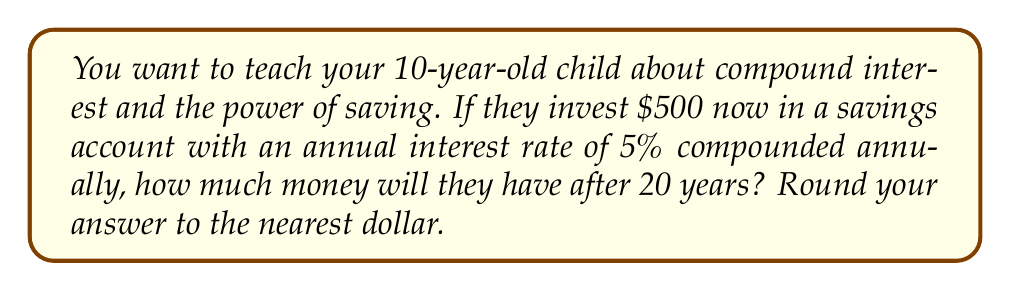Provide a solution to this math problem. To solve this problem, we'll use the compound interest formula:

$$A = P(1 + r)^n$$

Where:
$A$ = final amount
$P$ = principal (initial investment)
$r$ = annual interest rate (as a decimal)
$n$ = number of years

Given:
$P = \$500$
$r = 5\% = 0.05$
$n = 20$ years

Let's substitute these values into the formula:

$$A = 500(1 + 0.05)^{20}$$

Now, let's calculate step-by-step:

1) First, calculate $(1 + 0.05)^{20}$:
   $1.05^{20} \approx 2.6532977$

2) Multiply this by the principal:
   $500 \times 2.6532977 \approx 1326.64885$

3) Round to the nearest dollar:
   $1326.64885 \approx \$1,327$

This calculation shows how the initial $500 grows over 20 years due to compound interest.
Answer: $1,327 